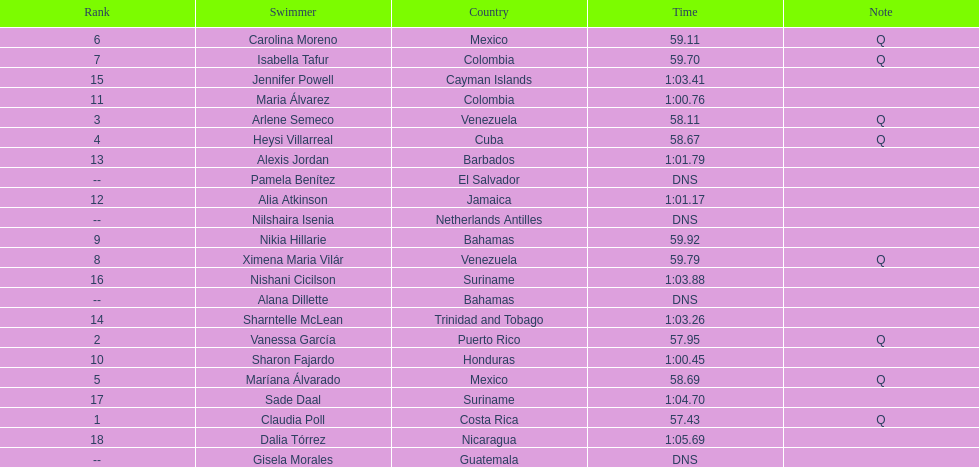Which swimmer had the longest time? Dalia Tórrez. 